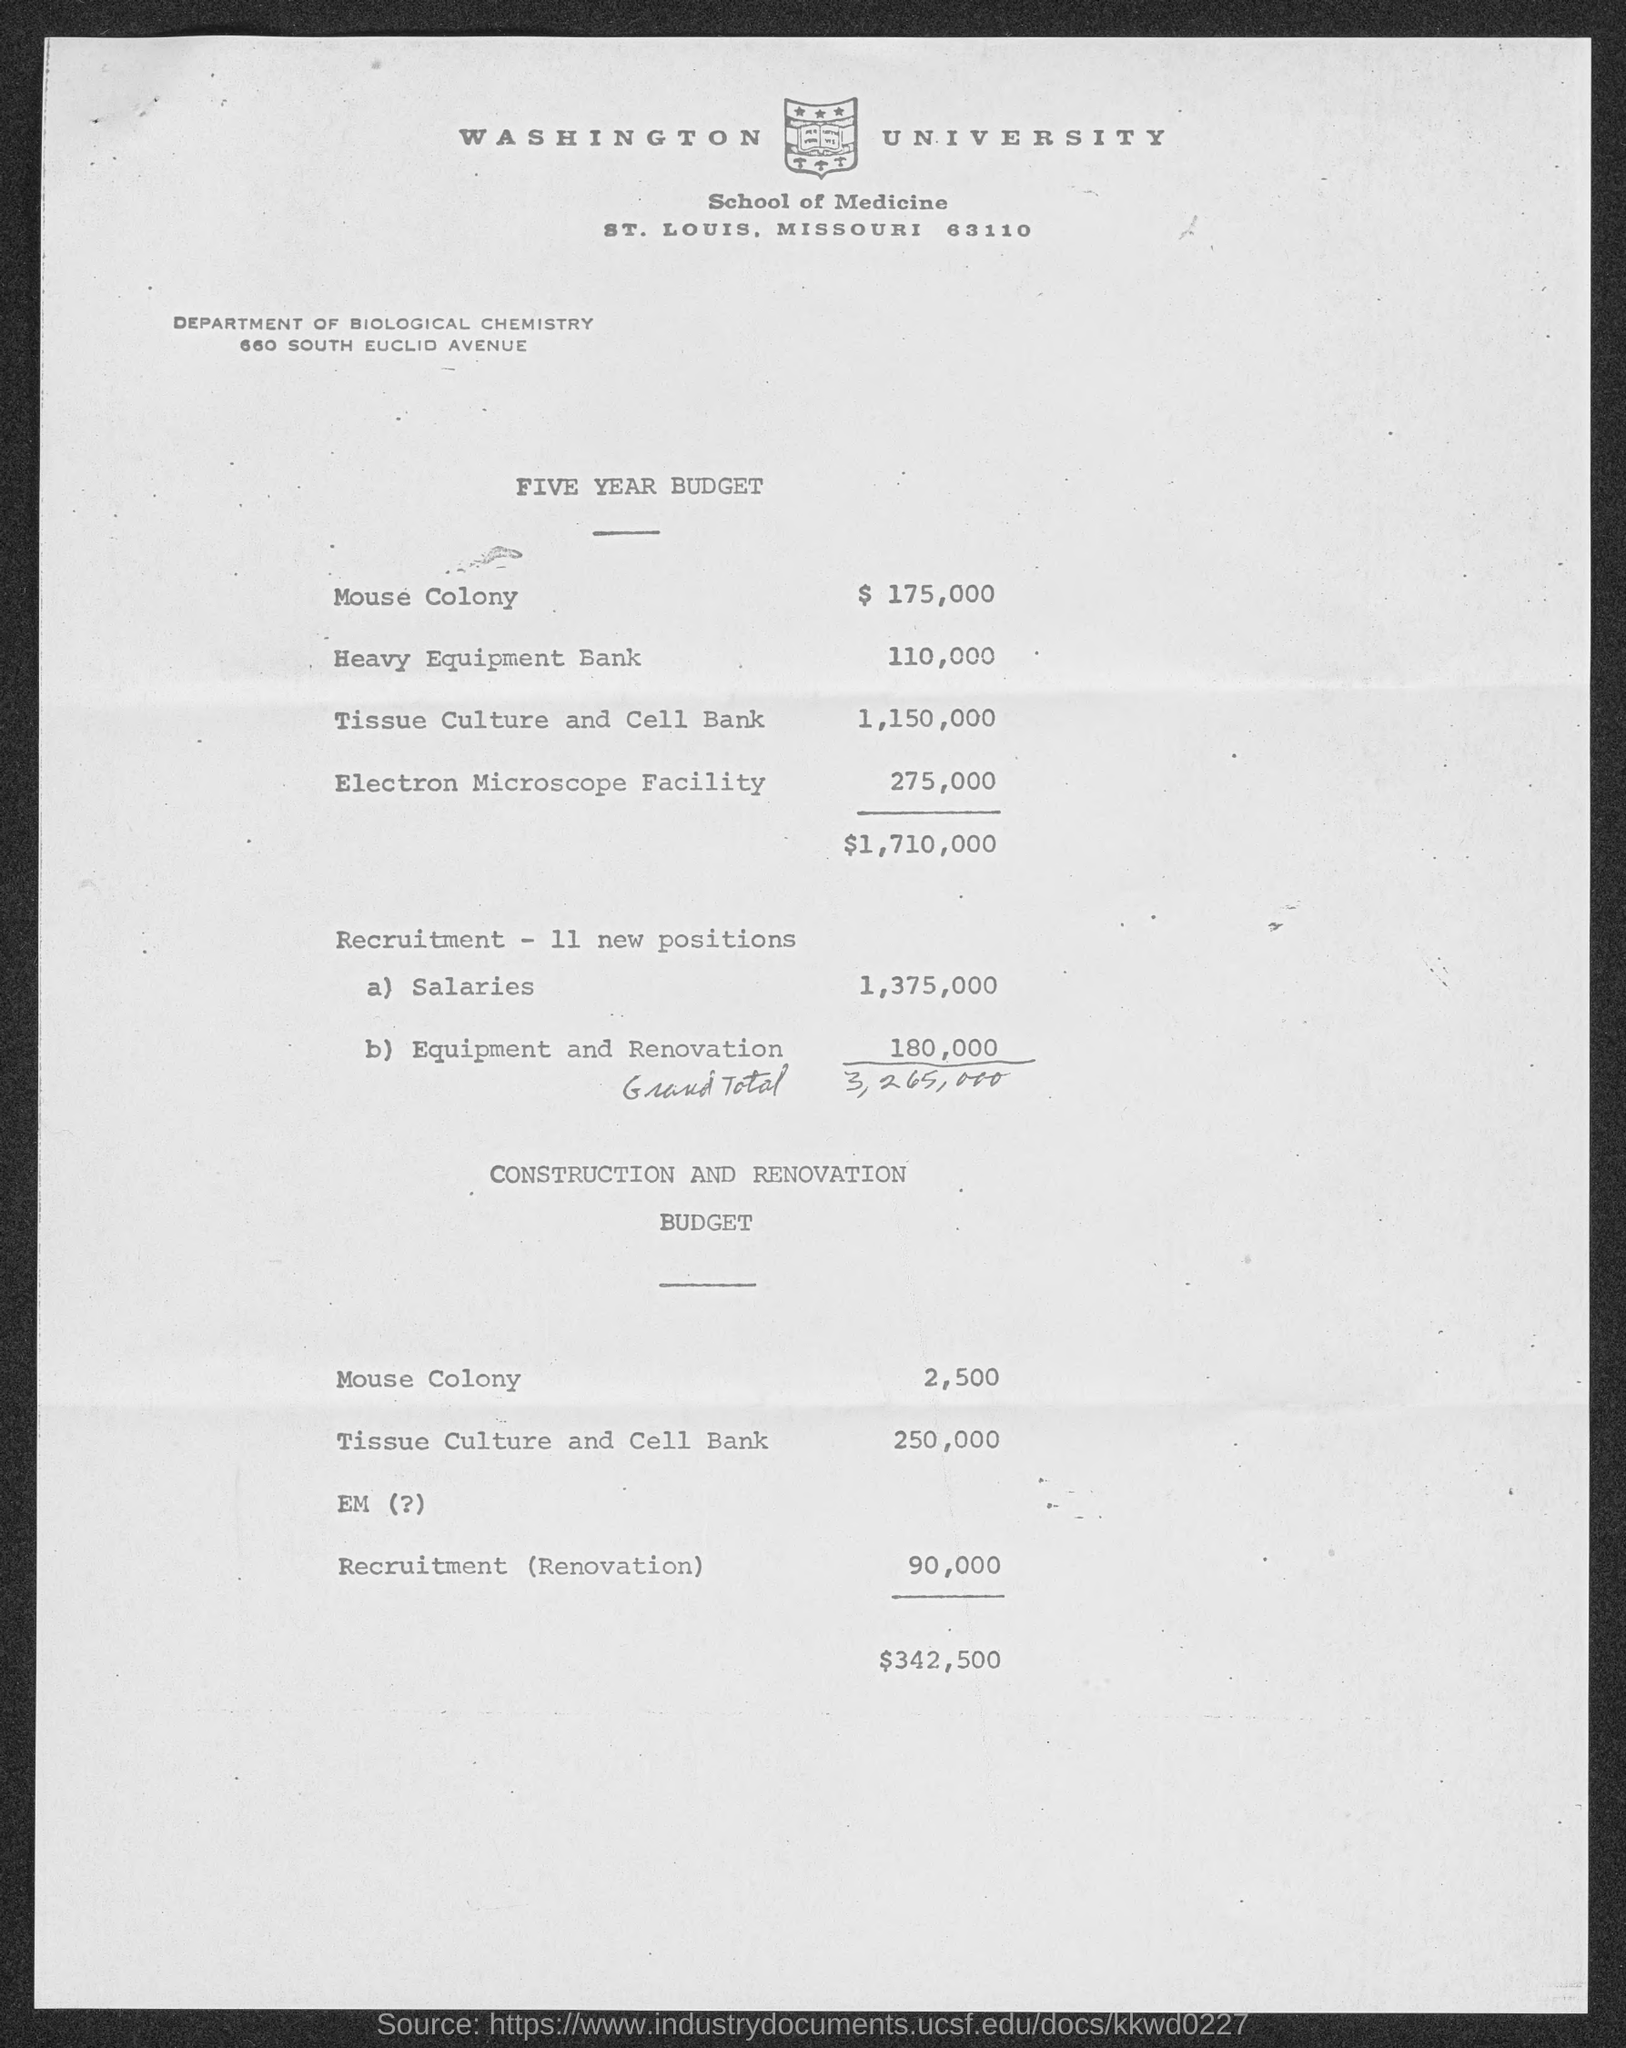Mention a couple of crucial points in this snapshot. The name of the university mentioned in the given page is Washington University. The amount allocated for a mouse colony in the construction and renovation budget is 2,500. The amount allocated for tissue culture and cell banking over the next five years is 1,150,000. The Department of Biological Chemistry is a department mentioned in the given page. The total budget for the electron microscope facility over the next five years is expected to be approximately $275,000. 